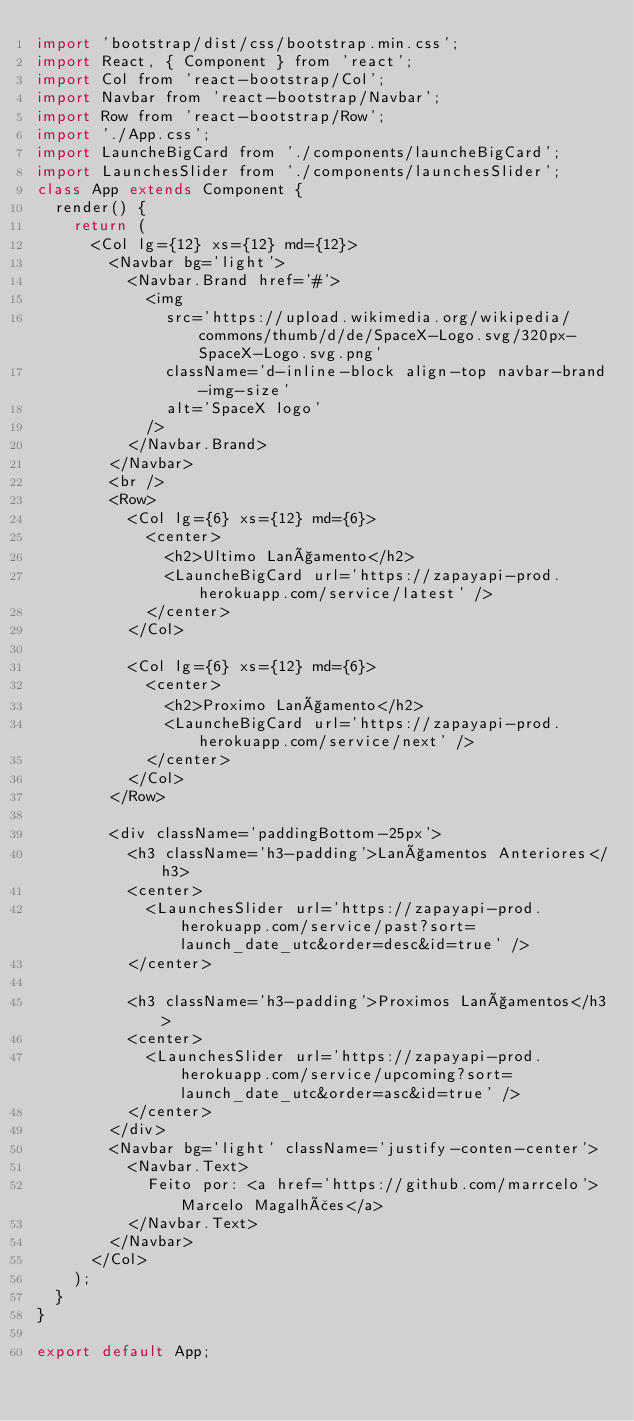Convert code to text. <code><loc_0><loc_0><loc_500><loc_500><_JavaScript_>import 'bootstrap/dist/css/bootstrap.min.css';
import React, { Component } from 'react';
import Col from 'react-bootstrap/Col';
import Navbar from 'react-bootstrap/Navbar';
import Row from 'react-bootstrap/Row';
import './App.css';
import LauncheBigCard from './components/launcheBigCard';
import LaunchesSlider from './components/launchesSlider';
class App extends Component {
  render() {
    return (
      <Col lg={12} xs={12} md={12}>
        <Navbar bg='light'>
          <Navbar.Brand href='#'>
            <img
              src='https://upload.wikimedia.org/wikipedia/commons/thumb/d/de/SpaceX-Logo.svg/320px-SpaceX-Logo.svg.png'
              className='d-inline-block align-top navbar-brand-img-size'
              alt='SpaceX logo'
            />
          </Navbar.Brand>
        </Navbar>
        <br />
        <Row>
          <Col lg={6} xs={12} md={6}>
            <center>
              <h2>Ultimo Lançamento</h2>
              <LauncheBigCard url='https://zapayapi-prod.herokuapp.com/service/latest' />
            </center>
          </Col>

          <Col lg={6} xs={12} md={6}>
            <center>
              <h2>Proximo Lançamento</h2>
              <LauncheBigCard url='https://zapayapi-prod.herokuapp.com/service/next' />
            </center>
          </Col>
        </Row>

        <div className='paddingBottom-25px'>
          <h3 className='h3-padding'>Lançamentos Anteriores</h3>
          <center>
            <LaunchesSlider url='https://zapayapi-prod.herokuapp.com/service/past?sort=launch_date_utc&order=desc&id=true' />
          </center>

          <h3 className='h3-padding'>Proximos Lançamentos</h3>
          <center>
            <LaunchesSlider url='https://zapayapi-prod.herokuapp.com/service/upcoming?sort=launch_date_utc&order=asc&id=true' />
          </center>
        </div>
        <Navbar bg='light' className='justify-conten-center'>
          <Navbar.Text>
            Feito por: <a href='https://github.com/marrcelo'>Marcelo Magalhães</a>
          </Navbar.Text>
        </Navbar>
      </Col>
    );
  }
}

export default App;</code> 